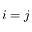Convert formula to latex. <formula><loc_0><loc_0><loc_500><loc_500>i = j</formula> 